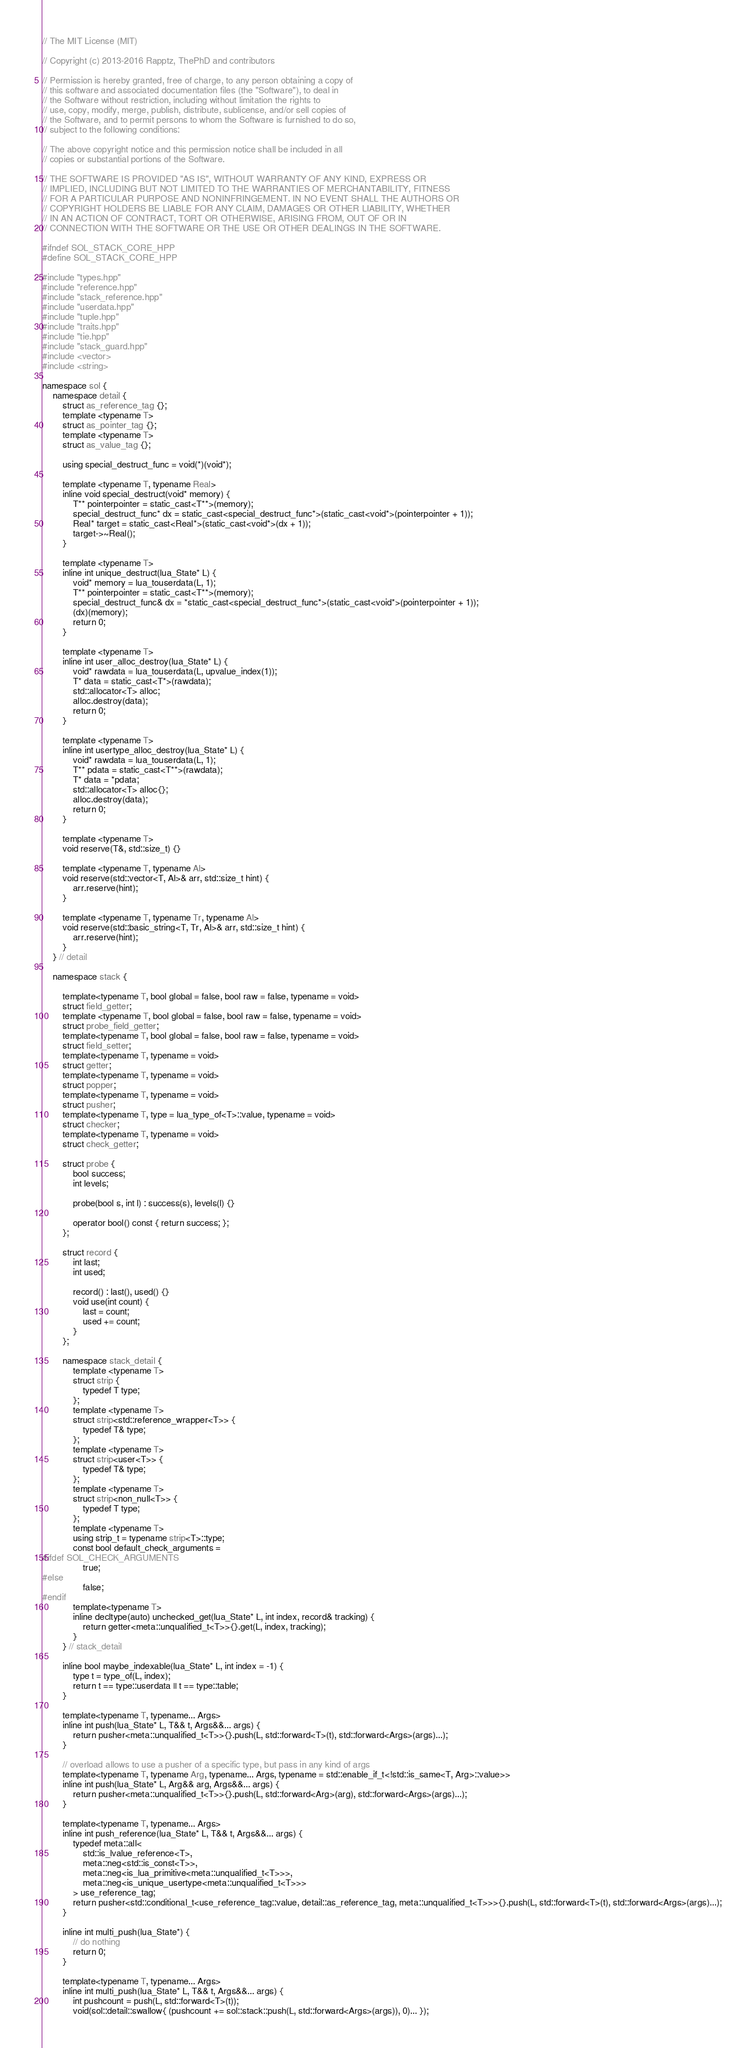<code> <loc_0><loc_0><loc_500><loc_500><_C++_>// The MIT License (MIT) 

// Copyright (c) 2013-2016 Rapptz, ThePhD and contributors

// Permission is hereby granted, free of charge, to any person obtaining a copy of
// this software and associated documentation files (the "Software"), to deal in
// the Software without restriction, including without limitation the rights to
// use, copy, modify, merge, publish, distribute, sublicense, and/or sell copies of
// the Software, and to permit persons to whom the Software is furnished to do so,
// subject to the following conditions:

// The above copyright notice and this permission notice shall be included in all
// copies or substantial portions of the Software.

// THE SOFTWARE IS PROVIDED "AS IS", WITHOUT WARRANTY OF ANY KIND, EXPRESS OR
// IMPLIED, INCLUDING BUT NOT LIMITED TO THE WARRANTIES OF MERCHANTABILITY, FITNESS
// FOR A PARTICULAR PURPOSE AND NONINFRINGEMENT. IN NO EVENT SHALL THE AUTHORS OR
// COPYRIGHT HOLDERS BE LIABLE FOR ANY CLAIM, DAMAGES OR OTHER LIABILITY, WHETHER
// IN AN ACTION OF CONTRACT, TORT OR OTHERWISE, ARISING FROM, OUT OF OR IN
// CONNECTION WITH THE SOFTWARE OR THE USE OR OTHER DEALINGS IN THE SOFTWARE.

#ifndef SOL_STACK_CORE_HPP
#define SOL_STACK_CORE_HPP

#include "types.hpp"
#include "reference.hpp"
#include "stack_reference.hpp"
#include "userdata.hpp"
#include "tuple.hpp"
#include "traits.hpp"
#include "tie.hpp"
#include "stack_guard.hpp"
#include <vector>
#include <string>

namespace sol {
	namespace detail {
		struct as_reference_tag {};
		template <typename T>
		struct as_pointer_tag {};
		template <typename T>
		struct as_value_tag {};

		using special_destruct_func = void(*)(void*);

		template <typename T, typename Real>
		inline void special_destruct(void* memory) {
			T** pointerpointer = static_cast<T**>(memory);
			special_destruct_func* dx = static_cast<special_destruct_func*>(static_cast<void*>(pointerpointer + 1));
			Real* target = static_cast<Real*>(static_cast<void*>(dx + 1));
			target->~Real();
		}

		template <typename T>
		inline int unique_destruct(lua_State* L) {
			void* memory = lua_touserdata(L, 1);
			T** pointerpointer = static_cast<T**>(memory);
			special_destruct_func& dx = *static_cast<special_destruct_func*>(static_cast<void*>(pointerpointer + 1));
			(dx)(memory);
			return 0;
		}

		template <typename T>
		inline int user_alloc_destroy(lua_State* L) {
			void* rawdata = lua_touserdata(L, upvalue_index(1));
			T* data = static_cast<T*>(rawdata);
			std::allocator<T> alloc;
			alloc.destroy(data);
			return 0;
		}

		template <typename T>
		inline int usertype_alloc_destroy(lua_State* L) {
			void* rawdata = lua_touserdata(L, 1);
			T** pdata = static_cast<T**>(rawdata);
			T* data = *pdata;
			std::allocator<T> alloc{};
			alloc.destroy(data);
			return 0;
		}

		template <typename T>
		void reserve(T&, std::size_t) {}

		template <typename T, typename Al>
		void reserve(std::vector<T, Al>& arr, std::size_t hint) {
			arr.reserve(hint);
		}

		template <typename T, typename Tr, typename Al>
		void reserve(std::basic_string<T, Tr, Al>& arr, std::size_t hint) {
			arr.reserve(hint);
		}
	} // detail

	namespace stack {

		template<typename T, bool global = false, bool raw = false, typename = void>
		struct field_getter;
		template <typename T, bool global = false, bool raw = false, typename = void>
		struct probe_field_getter;
		template<typename T, bool global = false, bool raw = false, typename = void>
		struct field_setter;
		template<typename T, typename = void>
		struct getter;
		template<typename T, typename = void>
		struct popper;
		template<typename T, typename = void>
		struct pusher;
		template<typename T, type = lua_type_of<T>::value, typename = void>
		struct checker;
		template<typename T, typename = void>
		struct check_getter;

		struct probe {
			bool success;
			int levels;

			probe(bool s, int l) : success(s), levels(l) {}

			operator bool() const { return success; };
		};

		struct record {
			int last;
			int used;

			record() : last(), used() {}
			void use(int count) {
				last = count;
				used += count;
			}
		};

		namespace stack_detail {
			template <typename T>
			struct strip {
				typedef T type;
			};
			template <typename T>
			struct strip<std::reference_wrapper<T>> {
				typedef T& type;
			};
			template <typename T>
			struct strip<user<T>> {
				typedef T& type;
			};
			template <typename T>
			struct strip<non_null<T>> {
				typedef T type;
			};
			template <typename T>
			using strip_t = typename strip<T>::type;
			const bool default_check_arguments =
#ifdef SOL_CHECK_ARGUMENTS
				true;
#else
				false;
#endif
			template<typename T>
			inline decltype(auto) unchecked_get(lua_State* L, int index, record& tracking) {
				return getter<meta::unqualified_t<T>>{}.get(L, index, tracking);
			}
		} // stack_detail

		inline bool maybe_indexable(lua_State* L, int index = -1) {
			type t = type_of(L, index);
			return t == type::userdata || t == type::table;
		}

		template<typename T, typename... Args>
		inline int push(lua_State* L, T&& t, Args&&... args) {
			return pusher<meta::unqualified_t<T>>{}.push(L, std::forward<T>(t), std::forward<Args>(args)...);
		}

		// overload allows to use a pusher of a specific type, but pass in any kind of args
		template<typename T, typename Arg, typename... Args, typename = std::enable_if_t<!std::is_same<T, Arg>::value>>
		inline int push(lua_State* L, Arg&& arg, Args&&... args) {
			return pusher<meta::unqualified_t<T>>{}.push(L, std::forward<Arg>(arg), std::forward<Args>(args)...);
		}

		template<typename T, typename... Args>
		inline int push_reference(lua_State* L, T&& t, Args&&... args) {
			typedef meta::all<
				std::is_lvalue_reference<T>,
				meta::neg<std::is_const<T>>,
				meta::neg<is_lua_primitive<meta::unqualified_t<T>>>,
				meta::neg<is_unique_usertype<meta::unqualified_t<T>>>
			> use_reference_tag;
			return pusher<std::conditional_t<use_reference_tag::value, detail::as_reference_tag, meta::unqualified_t<T>>>{}.push(L, std::forward<T>(t), std::forward<Args>(args)...);
		}

		inline int multi_push(lua_State*) {
			// do nothing
			return 0;
		}

		template<typename T, typename... Args>
		inline int multi_push(lua_State* L, T&& t, Args&&... args) {
			int pushcount = push(L, std::forward<T>(t));
			void(sol::detail::swallow{ (pushcount += sol::stack::push(L, std::forward<Args>(args)), 0)... });</code> 